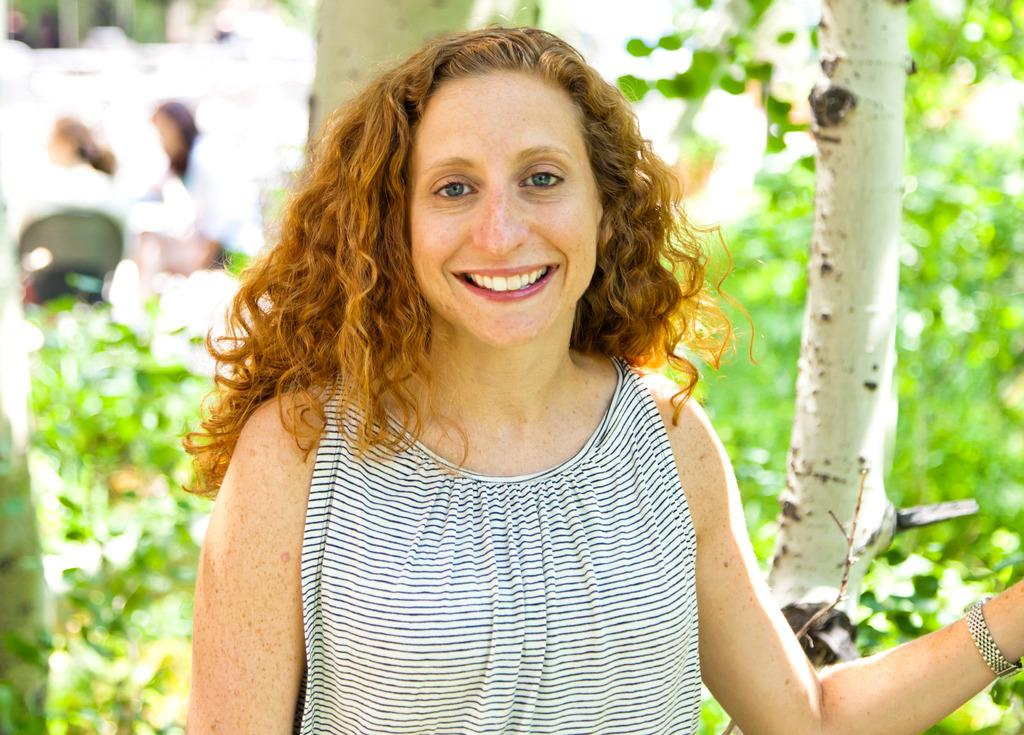Who is present in the image? There is a woman in the image. What is the woman's expression? The woman is smiling. What can be seen in the background of the image? There is a chair, two people, and trees in the background of the image. How would you describe the background of the image? The background of the image is blurry. What type of stove can be seen in the image? There is no stove present in the image. What sound is coming from the window in the image? There is no window or sound mentioned in the image. 